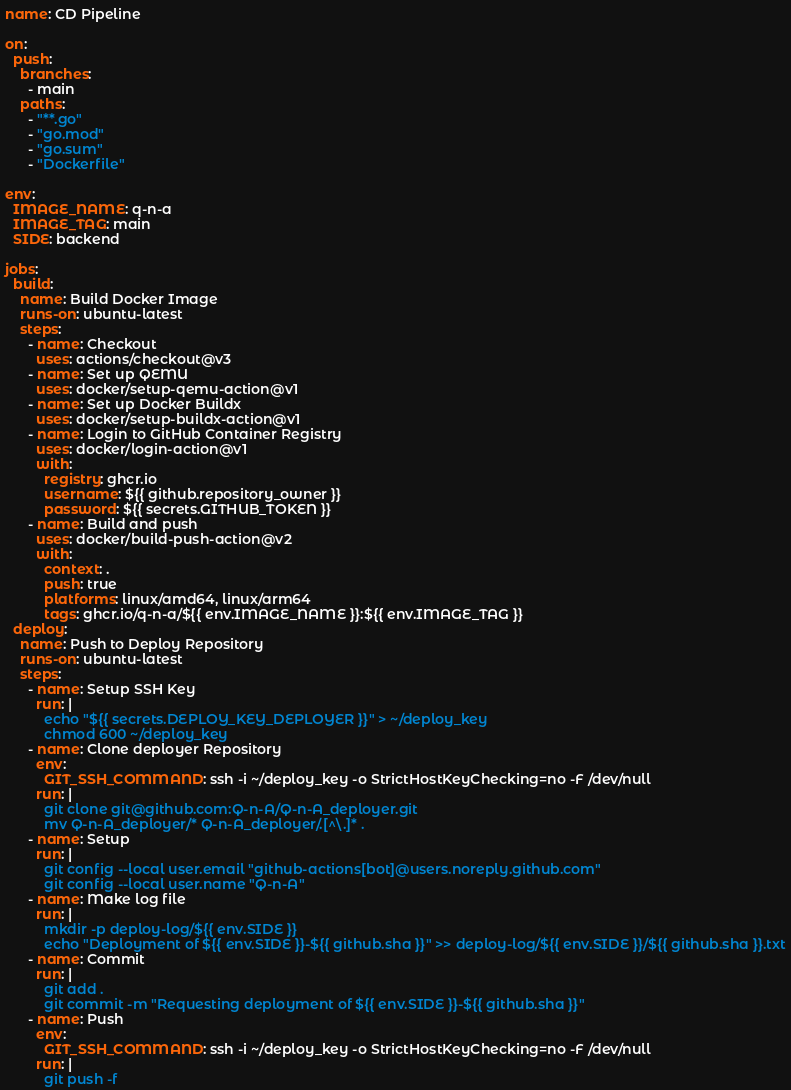Convert code to text. <code><loc_0><loc_0><loc_500><loc_500><_YAML_>name: CD Pipeline

on:
  push:
    branches:
      - main
    paths:
      - "**.go"
      - "go.mod"
      - "go.sum"
      - "Dockerfile"

env:
  IMAGE_NAME: q-n-a
  IMAGE_TAG: main
  SIDE: backend

jobs:
  build:
    name: Build Docker Image
    runs-on: ubuntu-latest
    steps:
      - name: Checkout
        uses: actions/checkout@v3
      - name: Set up QEMU
        uses: docker/setup-qemu-action@v1
      - name: Set up Docker Buildx
        uses: docker/setup-buildx-action@v1
      - name: Login to GitHub Container Registry
        uses: docker/login-action@v1
        with:
          registry: ghcr.io
          username: ${{ github.repository_owner }}
          password: ${{ secrets.GITHUB_TOKEN }}
      - name: Build and push
        uses: docker/build-push-action@v2
        with:
          context: .
          push: true
          platforms: linux/amd64, linux/arm64
          tags: ghcr.io/q-n-a/${{ env.IMAGE_NAME }}:${{ env.IMAGE_TAG }}
  deploy:
    name: Push to Deploy Repository
    runs-on: ubuntu-latest
    steps:
      - name: Setup SSH Key
        run: |
          echo "${{ secrets.DEPLOY_KEY_DEPLOYER }}" > ~/deploy_key
          chmod 600 ~/deploy_key
      - name: Clone deployer Repository
        env:
          GIT_SSH_COMMAND: ssh -i ~/deploy_key -o StrictHostKeyChecking=no -F /dev/null
        run: |
          git clone git@github.com:Q-n-A/Q-n-A_deployer.git
          mv Q-n-A_deployer/* Q-n-A_deployer/.[^\.]* .
      - name: Setup
        run: |
          git config --local user.email "github-actions[bot]@users.noreply.github.com"
          git config --local user.name "Q-n-A"
      - name: Make log file
        run: |
          mkdir -p deploy-log/${{ env.SIDE }}
          echo "Deployment of ${{ env.SIDE }}-${{ github.sha }}" >> deploy-log/${{ env.SIDE }}/${{ github.sha }}.txt
      - name: Commit
        run: |
          git add .
          git commit -m "Requesting deployment of ${{ env.SIDE }}-${{ github.sha }}"
      - name: Push
        env:
          GIT_SSH_COMMAND: ssh -i ~/deploy_key -o StrictHostKeyChecking=no -F /dev/null
        run: |
          git push -f
</code> 